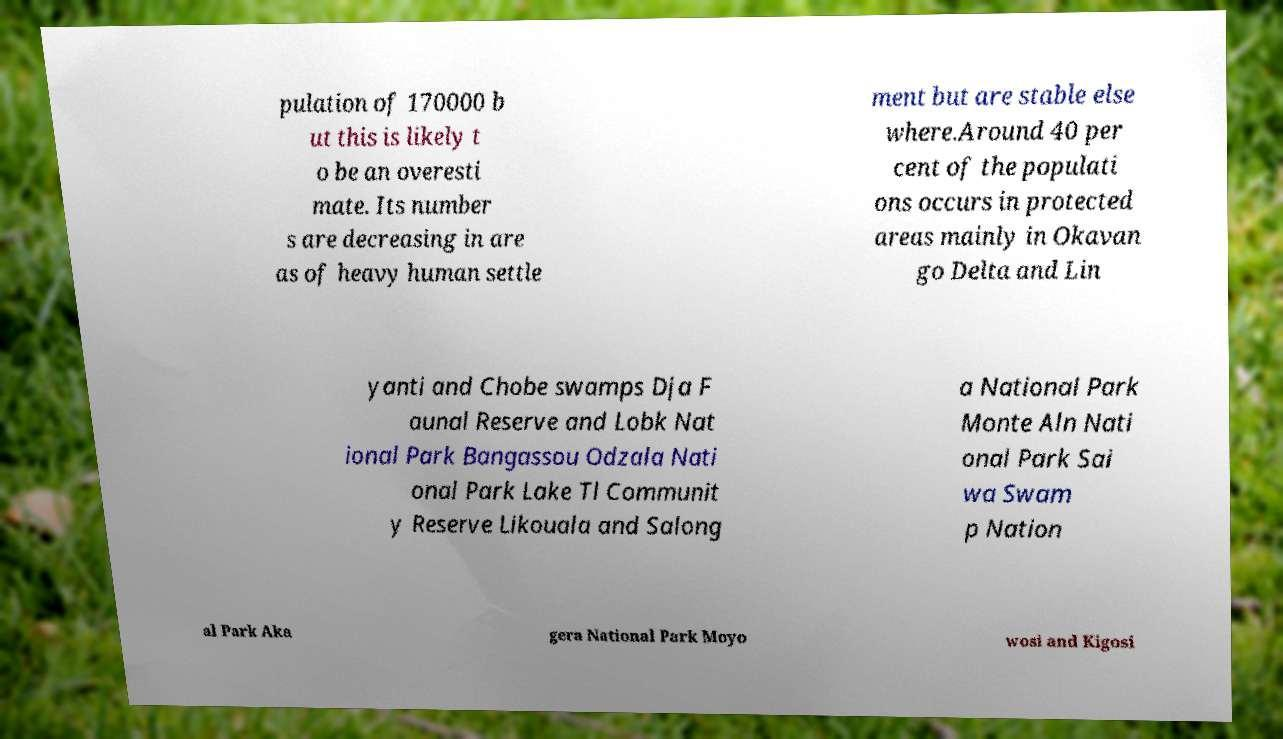Could you extract and type out the text from this image? pulation of 170000 b ut this is likely t o be an overesti mate. Its number s are decreasing in are as of heavy human settle ment but are stable else where.Around 40 per cent of the populati ons occurs in protected areas mainly in Okavan go Delta and Lin yanti and Chobe swamps Dja F aunal Reserve and Lobk Nat ional Park Bangassou Odzala Nati onal Park Lake Tl Communit y Reserve Likouala and Salong a National Park Monte Aln Nati onal Park Sai wa Swam p Nation al Park Aka gera National Park Moyo wosi and Kigosi 